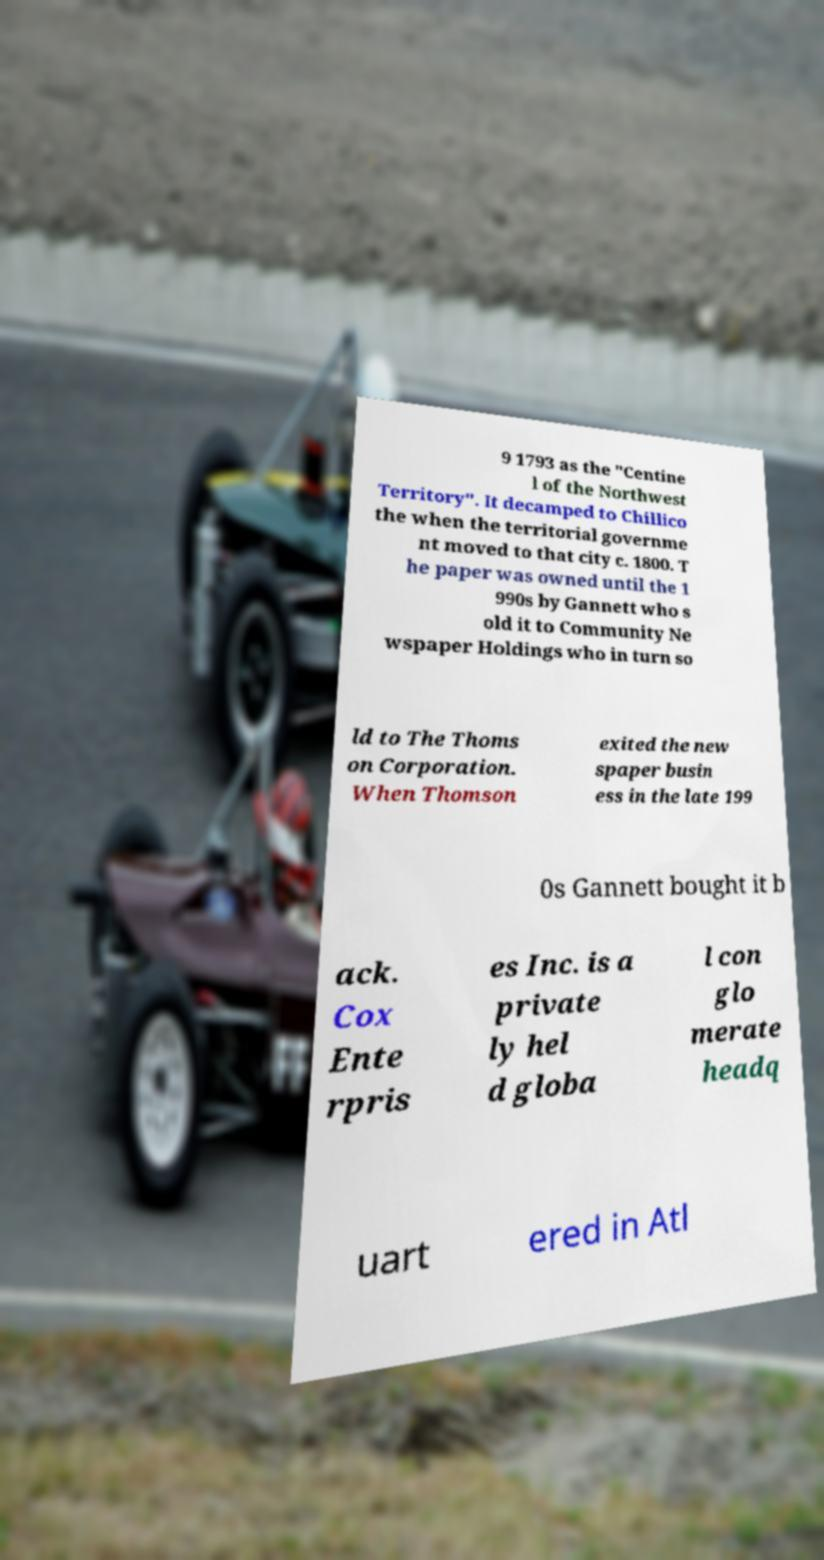Can you accurately transcribe the text from the provided image for me? 9 1793 as the "Centine l of the Northwest Territory". It decamped to Chillico the when the territorial governme nt moved to that city c. 1800. T he paper was owned until the 1 990s by Gannett who s old it to Community Ne wspaper Holdings who in turn so ld to The Thoms on Corporation. When Thomson exited the new spaper busin ess in the late 199 0s Gannett bought it b ack. Cox Ente rpris es Inc. is a private ly hel d globa l con glo merate headq uart ered in Atl 